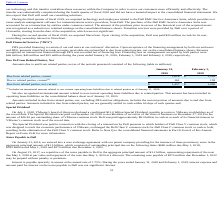According to Vmware's financial document, What did amounts due to related parties, current include? an immaterial amount related to our current operating lease liabilities due to related parties as of January 31, 2020. The document states: "(1) Includes an immaterial amount related to our current operating lease liabilities due to related parties as of January 31, 2020...." Also, What was the amount due to related parties, current in 2020? According to the financial document, 161 (in millions). The relevant text states: "Due to related parties, current (1) 161 158..." Also, What was the amount due from related parties, net, current in 2019? According to the financial document, 1,090 (in millions). The relevant text states: "Due from related parties, net, current $ 1,457 $ 1,090..." Also, can you calculate: What was the change in the current amount due from related parties between 2019 and 2020? Based on the calculation: 1,618-1,248, the result is 370 (in millions). This is based on the information: "Due from related parties, current $ 1,618 $ 1,248 Due from related parties, current $ 1,618 $ 1,248..." The key data points involved are: 1,248, 1,618. Also, How many years did current amounts due to related parties exceed $100 million? Counting the relevant items in the document: 2020, 2019, I find 2 instances. The key data points involved are: 2019, 2020. Also, can you calculate: What was the percentage change in the current net amount due from related parties between 2019 and 2020? To answer this question, I need to perform calculations using the financial data. The calculation is: (1,457-1,090)/1,090, which equals 33.67 (percentage). This is based on the information: "Due from related parties, net, current $ 1,457 $ 1,090 Due from related parties, net, current $ 1,457 $ 1,090..." The key data points involved are: 1,090, 1,457. 